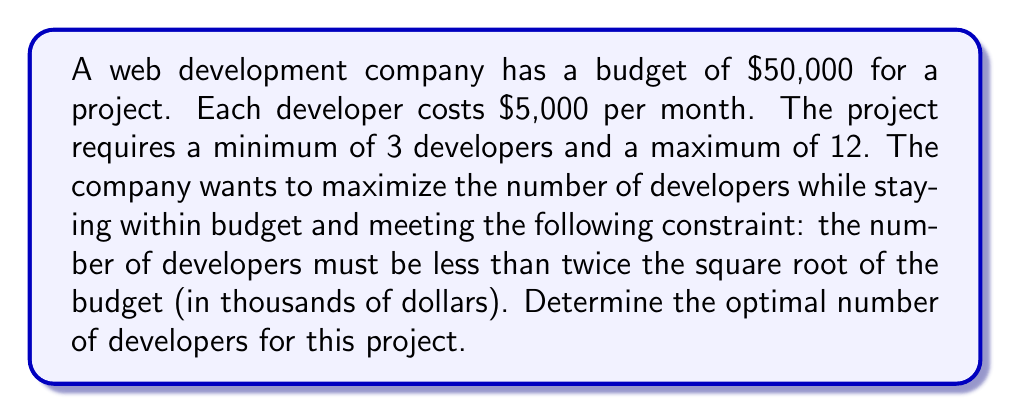Can you answer this question? Let's approach this step-by-step:

1) Let $x$ be the number of developers.

2) Given constraints:
   - Minimum: $x \geq 3$
   - Maximum: $x \leq 12$
   - Budget: $5000x \leq 50000$
   - Additional constraint: $x < 2\sqrt{\text{budget in thousands}}$

3) Simplify the budget constraint:
   $5000x \leq 50000$
   $x \leq 10$

4) Simplify the additional constraint:
   $x < 2\sqrt{50}$ (since the budget is $50,000)
   $x < 2 \cdot 7.071 \approx 14.142$

5) Combining all constraints:
   $3 \leq x \leq 10$ and $x < 14.142$

6) Since we want to maximize $x$ within these constraints, and $x$ must be an integer, the largest possible value is 10.

7) Verify:
   - 10 is between 3 and 12
   - $10 < 2\sqrt{50}$
   - $5000 \cdot 10 = 50000$, which meets the budget

Therefore, the optimal number of developers is 10.
Answer: 10 developers 